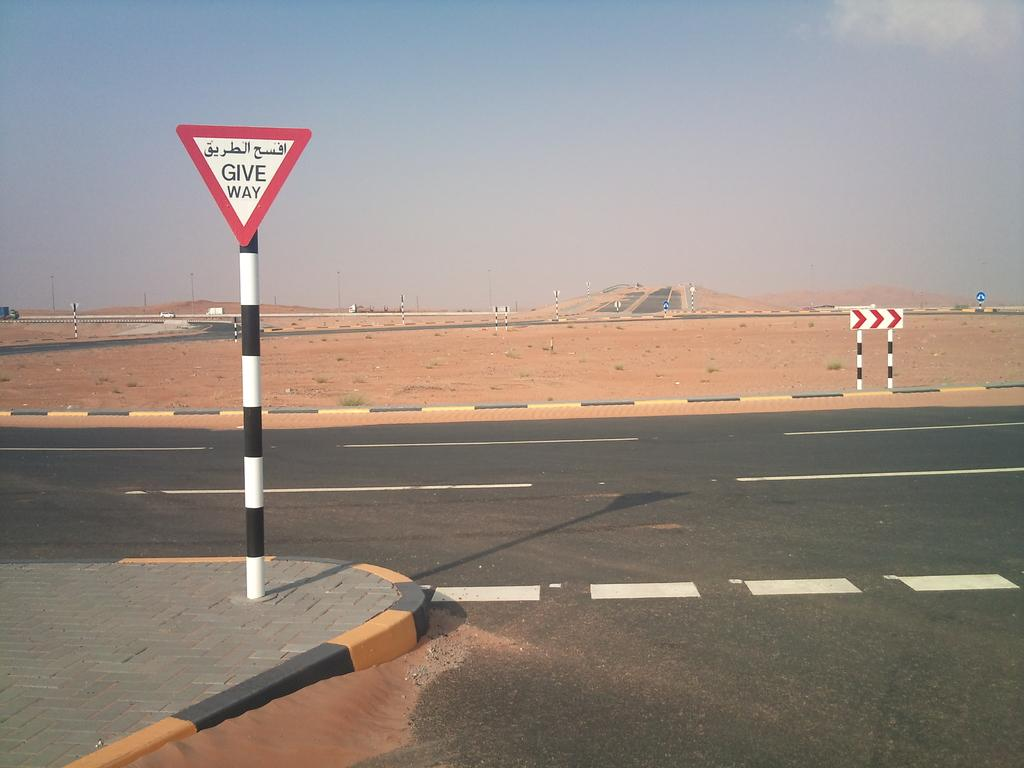What is the main feature of the image? There is a road in the image. What is located on the left side of the road? There is a caution board on the left side of the road. Where is the caution board placed? The caution board is on a footpath. What type of surface is visible behind the road? There is a sand surface behind the road. What color is the silver drain visible in the image? There is no silver drain present in the image. 